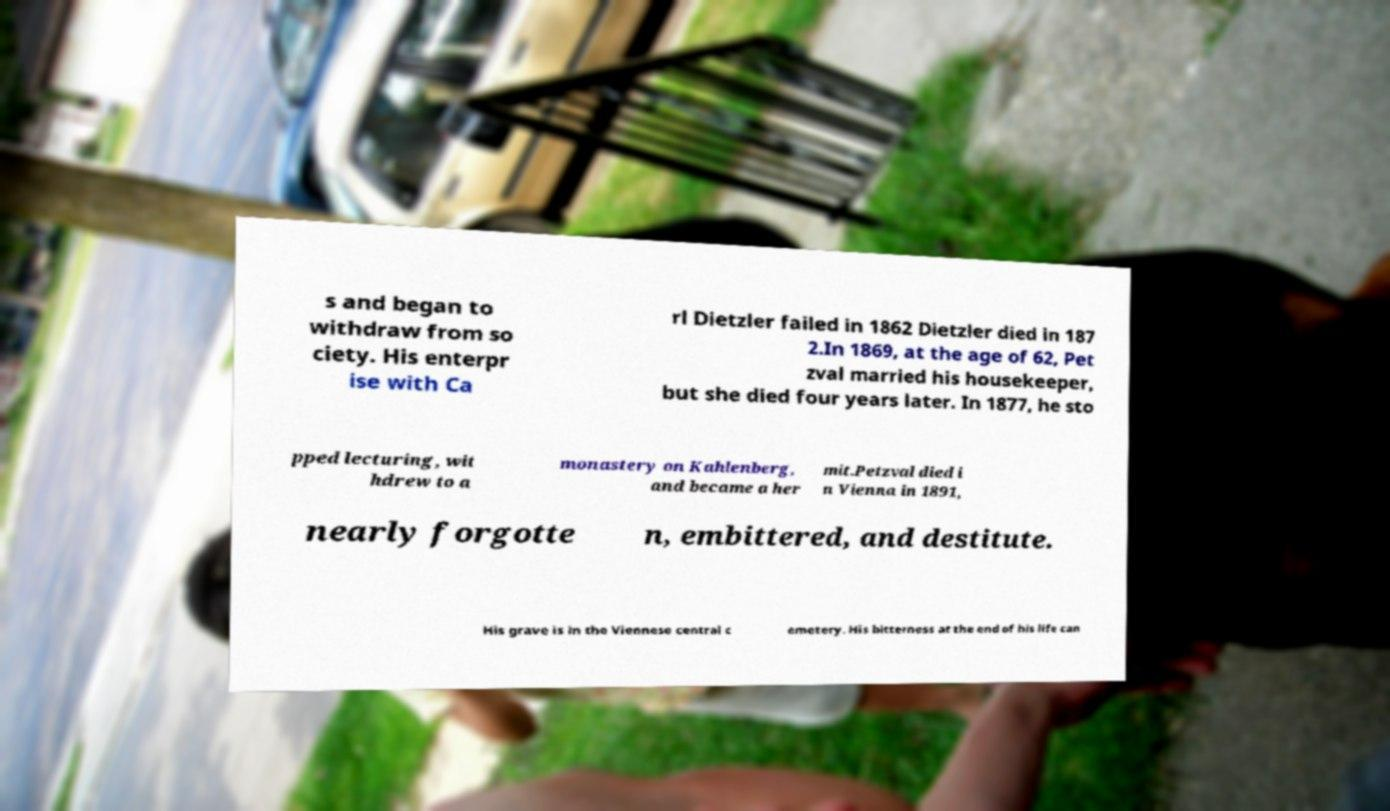Could you extract and type out the text from this image? s and began to withdraw from so ciety. His enterpr ise with Ca rl Dietzler failed in 1862 Dietzler died in 187 2.In 1869, at the age of 62, Pet zval married his housekeeper, but she died four years later. In 1877, he sto pped lecturing, wit hdrew to a monastery on Kahlenberg, and became a her mit.Petzval died i n Vienna in 1891, nearly forgotte n, embittered, and destitute. His grave is in the Viennese central c emetery. His bitterness at the end of his life can 